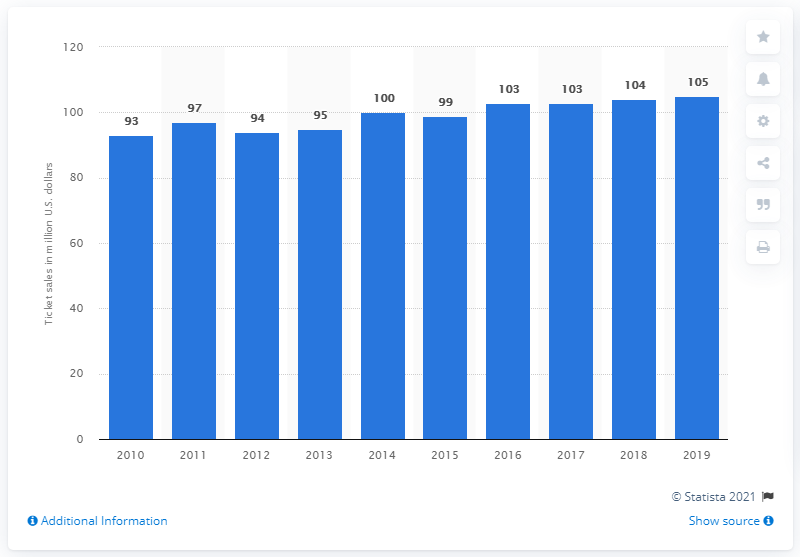Highlight a few significant elements in this photo. The New England Patriots generated approximately $105 million in revenue from gate receipts in 2019. 